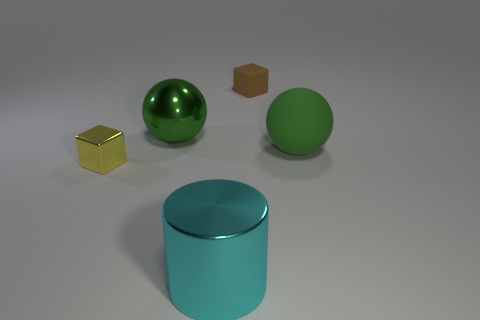Does the metallic sphere have the same color as the big matte ball?
Ensure brevity in your answer.  Yes. Does the cylinder that is in front of the big green shiny sphere have the same material as the small yellow thing?
Provide a short and direct response. Yes. What size is the green thing to the right of the cyan object?
Keep it short and to the point. Large. There is a tiny object in front of the shiny sphere; are there any cyan metal objects right of it?
Ensure brevity in your answer.  Yes. There is a matte sphere right of the tiny brown rubber object; is it the same color as the sphere that is to the left of the tiny brown object?
Make the answer very short. Yes. The small metal block has what color?
Offer a terse response. Yellow. Is there anything else that has the same color as the rubber cube?
Ensure brevity in your answer.  No. There is a metal object that is behind the big cyan shiny object and on the right side of the tiny yellow block; what is its color?
Ensure brevity in your answer.  Green. There is a ball in front of the green shiny object; is its size the same as the cylinder?
Your answer should be compact. Yes. Is the number of green balls that are behind the yellow shiny block greater than the number of large green matte things?
Offer a terse response. Yes. 